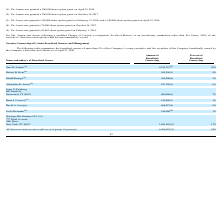From Protagenic Therapeutics's financial document, What is the amount and percent of beneficial ownership owned by Garo H. Armen?  The document shows two values: 4,741,323 and 36%. From the document: "Garo H. Armen (1) 4,741,323 (2) 36% Garo H. Armen (1) 4,741,323 (2) 36%..." Also, What is the amount and percent of beneficial ownership owned by Robert B. Stein? The document shows two values: 502,500 and 4%. From the document: "Robert B. Stein (1) 502,500 (3) 4% Robert B. Stein (1) 502,500 (3) 4%..." Also, What is the amount and percent of beneficial ownership owned by Khalil Barrage? The document shows two values: 380,000 and 3%. From the document: "Khalil Barrage (1) 380,000 (4) 3% Khalil Barrage (1) 380,000 (4) 3%..." Additionally, Who owns the largest percent of beneficial ownership? According to the financial document, Garo H. Armen. The relevant text states: "Garo H. Armen (1) 4,741,323 (2) 36%..." Additionally, Who owns the smallest percent of beneficial ownership? According to the financial document, Josh Silverman. The relevant text states: "Josh Silverman (1) 140,000 (9) 1%..." Also, can you calculate: What is the proportion of Josh Silverman's beneficial ownership as a percentage of Larry N. Feinberg's beneficial ownership? Based on the calculation: 140,000/800,000 , the result is 17.5 (percentage). This is based on the information: "Josh Silverman (1) 140,000 (9) 1% ry N. Feinberg 808 North St., Greenwich, CT 06831 800,000 (6) 7%..." The key data points involved are: 140,000, 800,000. 